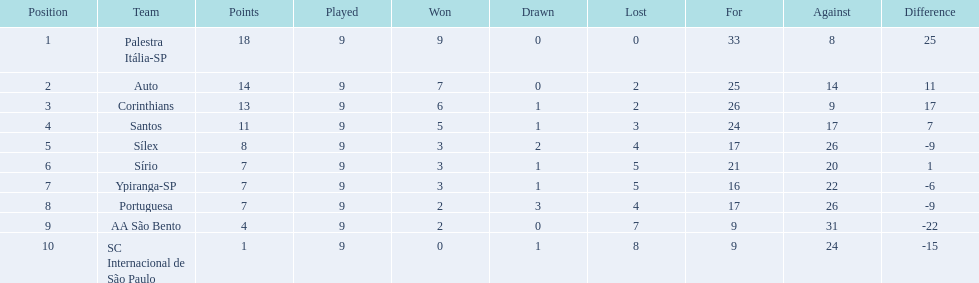How many matches did each squad participate in? 9, 9, 9, 9, 9, 9, 9, 9, 9, 9. Did any squad accumulate 13 points in the overall matches they took part in? 13. What is the name of that squad? Corinthians. 